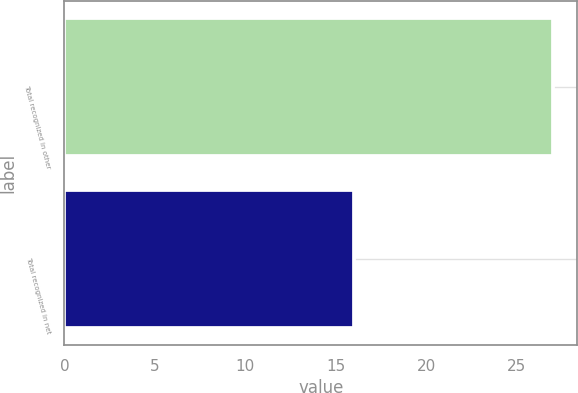Convert chart. <chart><loc_0><loc_0><loc_500><loc_500><bar_chart><fcel>Total recognized in other<fcel>Total recognized in net<nl><fcel>27<fcel>16<nl></chart> 